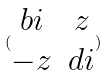Convert formula to latex. <formula><loc_0><loc_0><loc_500><loc_500>( \begin{matrix} b i & z \\ - z & d i \end{matrix} )</formula> 